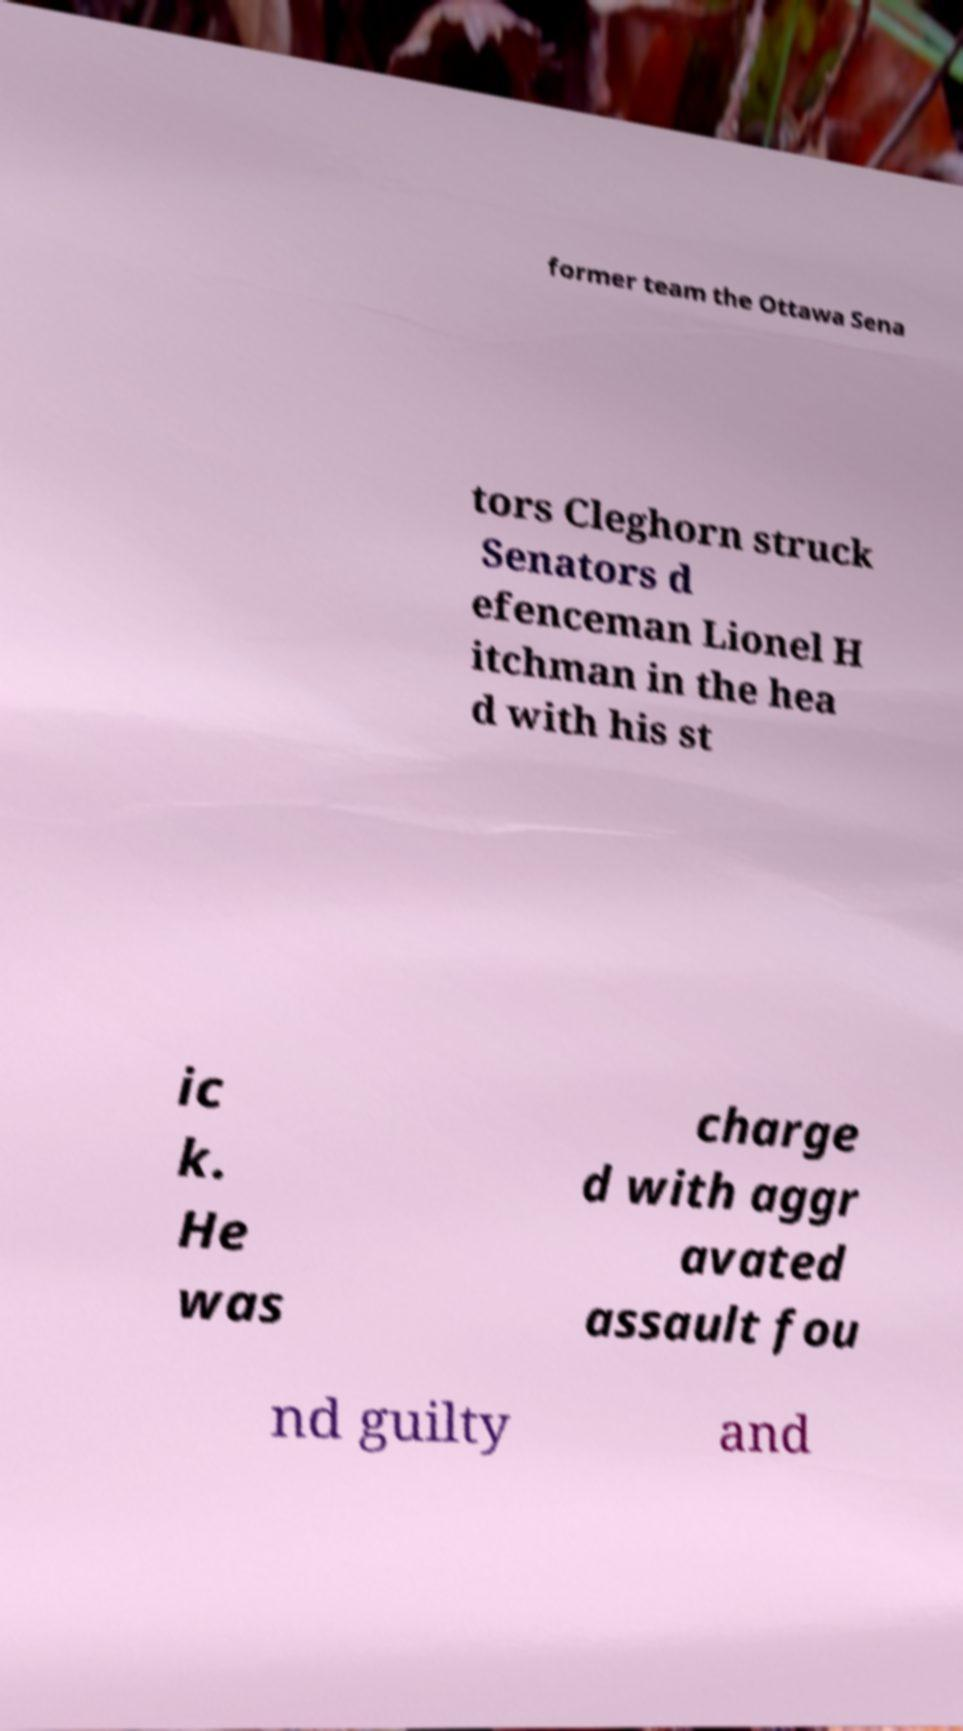I need the written content from this picture converted into text. Can you do that? former team the Ottawa Sena tors Cleghorn struck Senators d efenceman Lionel H itchman in the hea d with his st ic k. He was charge d with aggr avated assault fou nd guilty and 